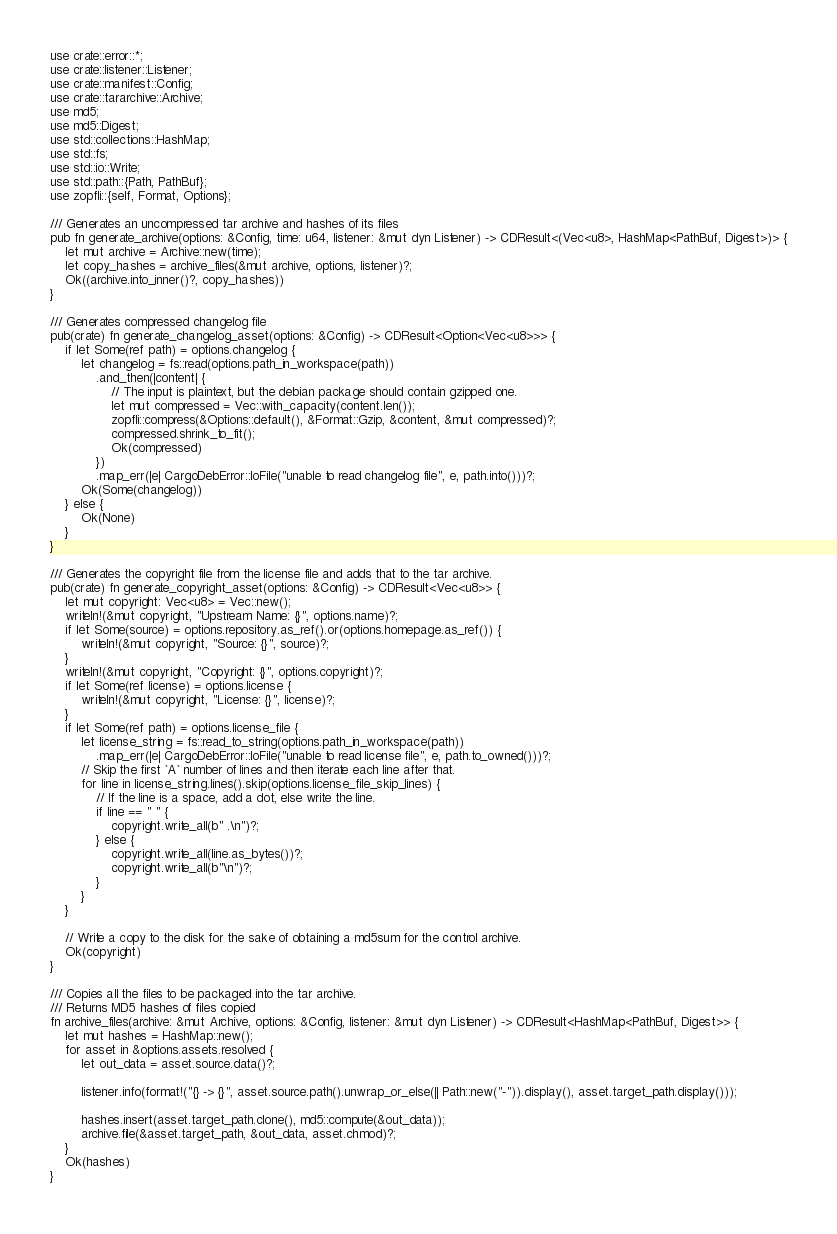<code> <loc_0><loc_0><loc_500><loc_500><_Rust_>use crate::error::*;
use crate::listener::Listener;
use crate::manifest::Config;
use crate::tararchive::Archive;
use md5;
use md5::Digest;
use std::collections::HashMap;
use std::fs;
use std::io::Write;
use std::path::{Path, PathBuf};
use zopfli::{self, Format, Options};

/// Generates an uncompressed tar archive and hashes of its files
pub fn generate_archive(options: &Config, time: u64, listener: &mut dyn Listener) -> CDResult<(Vec<u8>, HashMap<PathBuf, Digest>)> {
    let mut archive = Archive::new(time);
    let copy_hashes = archive_files(&mut archive, options, listener)?;
    Ok((archive.into_inner()?, copy_hashes))
}

/// Generates compressed changelog file
pub(crate) fn generate_changelog_asset(options: &Config) -> CDResult<Option<Vec<u8>>> {
    if let Some(ref path) = options.changelog {
        let changelog = fs::read(options.path_in_workspace(path))
            .and_then(|content| {
                // The input is plaintext, but the debian package should contain gzipped one.
                let mut compressed = Vec::with_capacity(content.len());
                zopfli::compress(&Options::default(), &Format::Gzip, &content, &mut compressed)?;
                compressed.shrink_to_fit();
                Ok(compressed)
            })
            .map_err(|e| CargoDebError::IoFile("unable to read changelog file", e, path.into()))?;
        Ok(Some(changelog))
    } else {
        Ok(None)
    }
}

/// Generates the copyright file from the license file and adds that to the tar archive.
pub(crate) fn generate_copyright_asset(options: &Config) -> CDResult<Vec<u8>> {
    let mut copyright: Vec<u8> = Vec::new();
    writeln!(&mut copyright, "Upstream Name: {}", options.name)?;
    if let Some(source) = options.repository.as_ref().or(options.homepage.as_ref()) {
        writeln!(&mut copyright, "Source: {}", source)?;
    }
    writeln!(&mut copyright, "Copyright: {}", options.copyright)?;
    if let Some(ref license) = options.license {
        writeln!(&mut copyright, "License: {}", license)?;
    }
    if let Some(ref path) = options.license_file {
        let license_string = fs::read_to_string(options.path_in_workspace(path))
            .map_err(|e| CargoDebError::IoFile("unable to read license file", e, path.to_owned()))?;
        // Skip the first `A` number of lines and then iterate each line after that.
        for line in license_string.lines().skip(options.license_file_skip_lines) {
            // If the line is a space, add a dot, else write the line.
            if line == " " {
                copyright.write_all(b" .\n")?;
            } else {
                copyright.write_all(line.as_bytes())?;
                copyright.write_all(b"\n")?;
            }
        }
    }

    // Write a copy to the disk for the sake of obtaining a md5sum for the control archive.
    Ok(copyright)
}

/// Copies all the files to be packaged into the tar archive.
/// Returns MD5 hashes of files copied
fn archive_files(archive: &mut Archive, options: &Config, listener: &mut dyn Listener) -> CDResult<HashMap<PathBuf, Digest>> {
    let mut hashes = HashMap::new();
    for asset in &options.assets.resolved {
        let out_data = asset.source.data()?;

        listener.info(format!("{} -> {}", asset.source.path().unwrap_or_else(|| Path::new("-")).display(), asset.target_path.display()));

        hashes.insert(asset.target_path.clone(), md5::compute(&out_data));
        archive.file(&asset.target_path, &out_data, asset.chmod)?;
    }
    Ok(hashes)
}
</code> 